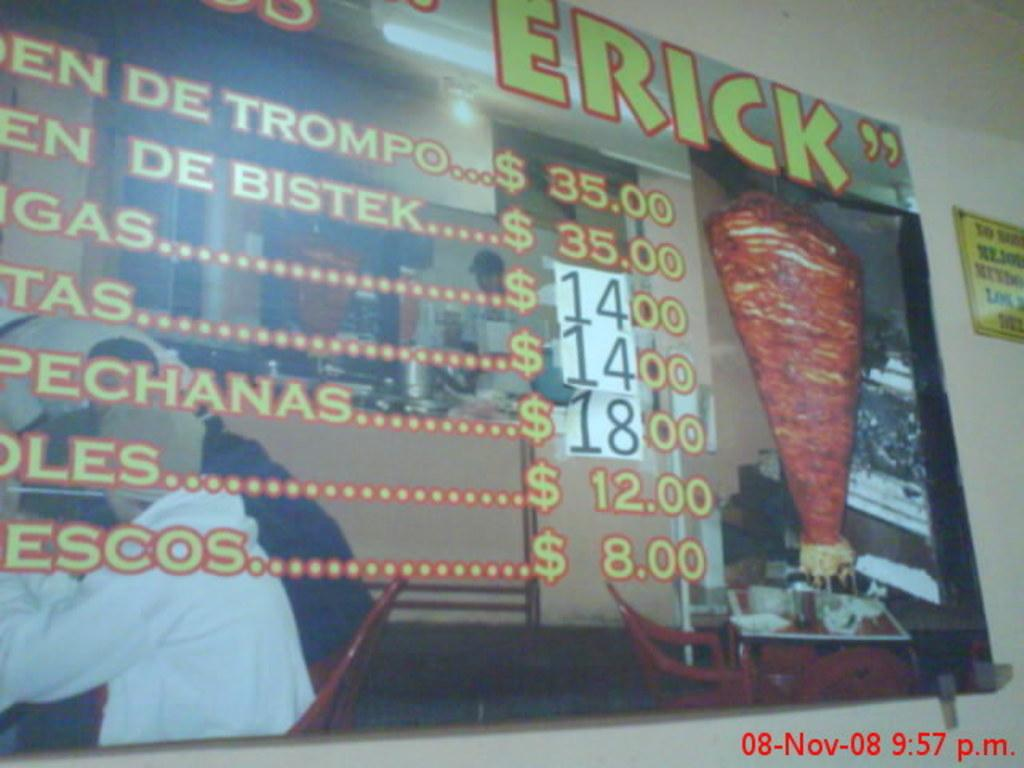Provide a one-sentence caption for the provided image. A large menu in a kebab shop showing prices ranging from $8.00 to $35.00. 